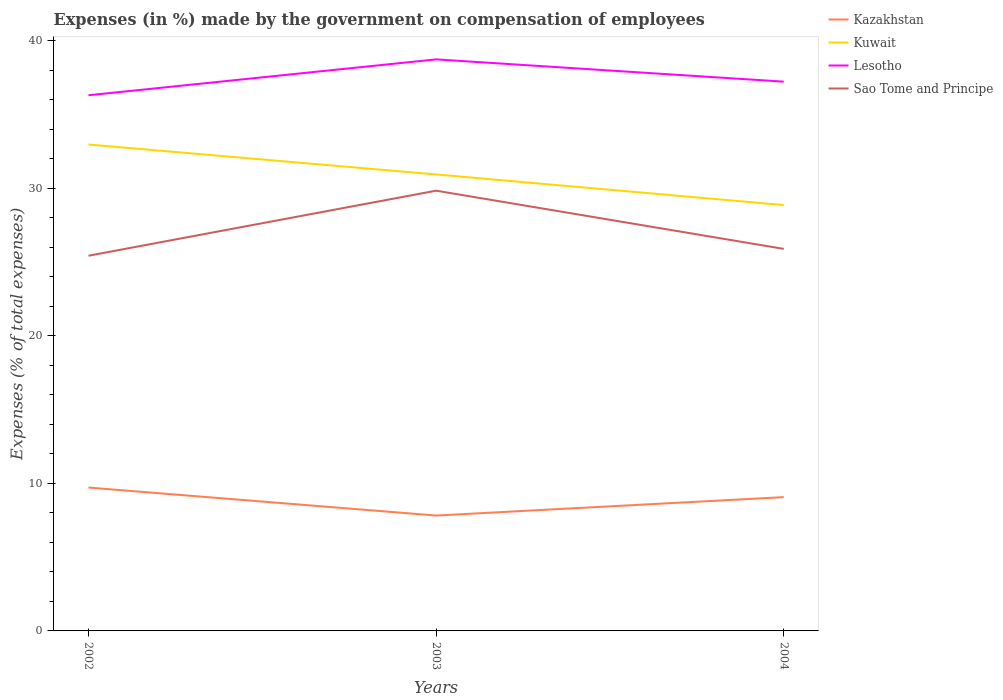How many different coloured lines are there?
Give a very brief answer. 4. Across all years, what is the maximum percentage of expenses made by the government on compensation of employees in Lesotho?
Ensure brevity in your answer.  36.29. In which year was the percentage of expenses made by the government on compensation of employees in Kuwait maximum?
Give a very brief answer. 2004. What is the total percentage of expenses made by the government on compensation of employees in Sao Tome and Principe in the graph?
Ensure brevity in your answer.  -0.46. What is the difference between the highest and the second highest percentage of expenses made by the government on compensation of employees in Lesotho?
Provide a short and direct response. 2.43. What is the difference between the highest and the lowest percentage of expenses made by the government on compensation of employees in Lesotho?
Ensure brevity in your answer.  1. How many lines are there?
Provide a short and direct response. 4. What is the difference between two consecutive major ticks on the Y-axis?
Make the answer very short. 10. Are the values on the major ticks of Y-axis written in scientific E-notation?
Provide a succinct answer. No. Does the graph contain any zero values?
Offer a terse response. No. Where does the legend appear in the graph?
Your answer should be compact. Top right. How many legend labels are there?
Offer a terse response. 4. What is the title of the graph?
Your answer should be compact. Expenses (in %) made by the government on compensation of employees. What is the label or title of the X-axis?
Provide a succinct answer. Years. What is the label or title of the Y-axis?
Provide a short and direct response. Expenses (% of total expenses). What is the Expenses (% of total expenses) in Kazakhstan in 2002?
Offer a very short reply. 9.71. What is the Expenses (% of total expenses) of Kuwait in 2002?
Your answer should be very brief. 32.96. What is the Expenses (% of total expenses) in Lesotho in 2002?
Make the answer very short. 36.29. What is the Expenses (% of total expenses) of Sao Tome and Principe in 2002?
Your answer should be very brief. 25.42. What is the Expenses (% of total expenses) in Kazakhstan in 2003?
Offer a terse response. 7.82. What is the Expenses (% of total expenses) in Kuwait in 2003?
Make the answer very short. 30.93. What is the Expenses (% of total expenses) in Lesotho in 2003?
Your answer should be compact. 38.72. What is the Expenses (% of total expenses) of Sao Tome and Principe in 2003?
Provide a succinct answer. 29.83. What is the Expenses (% of total expenses) of Kazakhstan in 2004?
Offer a terse response. 9.07. What is the Expenses (% of total expenses) in Kuwait in 2004?
Offer a very short reply. 28.85. What is the Expenses (% of total expenses) in Lesotho in 2004?
Your answer should be very brief. 37.21. What is the Expenses (% of total expenses) of Sao Tome and Principe in 2004?
Make the answer very short. 25.88. Across all years, what is the maximum Expenses (% of total expenses) in Kazakhstan?
Your answer should be compact. 9.71. Across all years, what is the maximum Expenses (% of total expenses) in Kuwait?
Offer a very short reply. 32.96. Across all years, what is the maximum Expenses (% of total expenses) of Lesotho?
Make the answer very short. 38.72. Across all years, what is the maximum Expenses (% of total expenses) in Sao Tome and Principe?
Provide a short and direct response. 29.83. Across all years, what is the minimum Expenses (% of total expenses) of Kazakhstan?
Offer a very short reply. 7.82. Across all years, what is the minimum Expenses (% of total expenses) in Kuwait?
Give a very brief answer. 28.85. Across all years, what is the minimum Expenses (% of total expenses) of Lesotho?
Your answer should be very brief. 36.29. Across all years, what is the minimum Expenses (% of total expenses) of Sao Tome and Principe?
Your answer should be compact. 25.42. What is the total Expenses (% of total expenses) of Kazakhstan in the graph?
Your answer should be very brief. 26.6. What is the total Expenses (% of total expenses) of Kuwait in the graph?
Give a very brief answer. 92.74. What is the total Expenses (% of total expenses) of Lesotho in the graph?
Your answer should be very brief. 112.23. What is the total Expenses (% of total expenses) of Sao Tome and Principe in the graph?
Ensure brevity in your answer.  81.13. What is the difference between the Expenses (% of total expenses) in Kazakhstan in 2002 and that in 2003?
Give a very brief answer. 1.9. What is the difference between the Expenses (% of total expenses) in Kuwait in 2002 and that in 2003?
Give a very brief answer. 2.03. What is the difference between the Expenses (% of total expenses) of Lesotho in 2002 and that in 2003?
Offer a terse response. -2.43. What is the difference between the Expenses (% of total expenses) of Sao Tome and Principe in 2002 and that in 2003?
Offer a terse response. -4.41. What is the difference between the Expenses (% of total expenses) of Kazakhstan in 2002 and that in 2004?
Provide a short and direct response. 0.65. What is the difference between the Expenses (% of total expenses) of Kuwait in 2002 and that in 2004?
Your answer should be very brief. 4.1. What is the difference between the Expenses (% of total expenses) of Lesotho in 2002 and that in 2004?
Your answer should be very brief. -0.92. What is the difference between the Expenses (% of total expenses) in Sao Tome and Principe in 2002 and that in 2004?
Offer a terse response. -0.46. What is the difference between the Expenses (% of total expenses) in Kazakhstan in 2003 and that in 2004?
Your answer should be compact. -1.25. What is the difference between the Expenses (% of total expenses) in Kuwait in 2003 and that in 2004?
Make the answer very short. 2.07. What is the difference between the Expenses (% of total expenses) in Lesotho in 2003 and that in 2004?
Your answer should be very brief. 1.51. What is the difference between the Expenses (% of total expenses) of Sao Tome and Principe in 2003 and that in 2004?
Provide a succinct answer. 3.94. What is the difference between the Expenses (% of total expenses) in Kazakhstan in 2002 and the Expenses (% of total expenses) in Kuwait in 2003?
Your answer should be very brief. -21.21. What is the difference between the Expenses (% of total expenses) of Kazakhstan in 2002 and the Expenses (% of total expenses) of Lesotho in 2003?
Your answer should be very brief. -29.01. What is the difference between the Expenses (% of total expenses) of Kazakhstan in 2002 and the Expenses (% of total expenses) of Sao Tome and Principe in 2003?
Provide a succinct answer. -20.11. What is the difference between the Expenses (% of total expenses) of Kuwait in 2002 and the Expenses (% of total expenses) of Lesotho in 2003?
Give a very brief answer. -5.77. What is the difference between the Expenses (% of total expenses) of Kuwait in 2002 and the Expenses (% of total expenses) of Sao Tome and Principe in 2003?
Offer a terse response. 3.13. What is the difference between the Expenses (% of total expenses) in Lesotho in 2002 and the Expenses (% of total expenses) in Sao Tome and Principe in 2003?
Make the answer very short. 6.46. What is the difference between the Expenses (% of total expenses) in Kazakhstan in 2002 and the Expenses (% of total expenses) in Kuwait in 2004?
Your answer should be very brief. -19.14. What is the difference between the Expenses (% of total expenses) of Kazakhstan in 2002 and the Expenses (% of total expenses) of Lesotho in 2004?
Ensure brevity in your answer.  -27.5. What is the difference between the Expenses (% of total expenses) in Kazakhstan in 2002 and the Expenses (% of total expenses) in Sao Tome and Principe in 2004?
Offer a terse response. -16.17. What is the difference between the Expenses (% of total expenses) of Kuwait in 2002 and the Expenses (% of total expenses) of Lesotho in 2004?
Your answer should be compact. -4.26. What is the difference between the Expenses (% of total expenses) in Kuwait in 2002 and the Expenses (% of total expenses) in Sao Tome and Principe in 2004?
Your answer should be very brief. 7.07. What is the difference between the Expenses (% of total expenses) in Lesotho in 2002 and the Expenses (% of total expenses) in Sao Tome and Principe in 2004?
Provide a short and direct response. 10.41. What is the difference between the Expenses (% of total expenses) of Kazakhstan in 2003 and the Expenses (% of total expenses) of Kuwait in 2004?
Keep it short and to the point. -21.04. What is the difference between the Expenses (% of total expenses) of Kazakhstan in 2003 and the Expenses (% of total expenses) of Lesotho in 2004?
Your response must be concise. -29.4. What is the difference between the Expenses (% of total expenses) in Kazakhstan in 2003 and the Expenses (% of total expenses) in Sao Tome and Principe in 2004?
Your response must be concise. -18.07. What is the difference between the Expenses (% of total expenses) of Kuwait in 2003 and the Expenses (% of total expenses) of Lesotho in 2004?
Offer a terse response. -6.29. What is the difference between the Expenses (% of total expenses) of Kuwait in 2003 and the Expenses (% of total expenses) of Sao Tome and Principe in 2004?
Your response must be concise. 5.04. What is the difference between the Expenses (% of total expenses) of Lesotho in 2003 and the Expenses (% of total expenses) of Sao Tome and Principe in 2004?
Give a very brief answer. 12.84. What is the average Expenses (% of total expenses) of Kazakhstan per year?
Provide a succinct answer. 8.87. What is the average Expenses (% of total expenses) of Kuwait per year?
Give a very brief answer. 30.91. What is the average Expenses (% of total expenses) in Lesotho per year?
Your response must be concise. 37.41. What is the average Expenses (% of total expenses) of Sao Tome and Principe per year?
Offer a very short reply. 27.04. In the year 2002, what is the difference between the Expenses (% of total expenses) of Kazakhstan and Expenses (% of total expenses) of Kuwait?
Give a very brief answer. -23.24. In the year 2002, what is the difference between the Expenses (% of total expenses) in Kazakhstan and Expenses (% of total expenses) in Lesotho?
Offer a terse response. -26.58. In the year 2002, what is the difference between the Expenses (% of total expenses) in Kazakhstan and Expenses (% of total expenses) in Sao Tome and Principe?
Give a very brief answer. -15.71. In the year 2002, what is the difference between the Expenses (% of total expenses) in Kuwait and Expenses (% of total expenses) in Lesotho?
Your response must be concise. -3.34. In the year 2002, what is the difference between the Expenses (% of total expenses) of Kuwait and Expenses (% of total expenses) of Sao Tome and Principe?
Offer a terse response. 7.54. In the year 2002, what is the difference between the Expenses (% of total expenses) in Lesotho and Expenses (% of total expenses) in Sao Tome and Principe?
Your answer should be very brief. 10.87. In the year 2003, what is the difference between the Expenses (% of total expenses) in Kazakhstan and Expenses (% of total expenses) in Kuwait?
Offer a very short reply. -23.11. In the year 2003, what is the difference between the Expenses (% of total expenses) in Kazakhstan and Expenses (% of total expenses) in Lesotho?
Provide a succinct answer. -30.91. In the year 2003, what is the difference between the Expenses (% of total expenses) in Kazakhstan and Expenses (% of total expenses) in Sao Tome and Principe?
Provide a succinct answer. -22.01. In the year 2003, what is the difference between the Expenses (% of total expenses) of Kuwait and Expenses (% of total expenses) of Lesotho?
Your answer should be very brief. -7.8. In the year 2003, what is the difference between the Expenses (% of total expenses) of Kuwait and Expenses (% of total expenses) of Sao Tome and Principe?
Your answer should be compact. 1.1. In the year 2003, what is the difference between the Expenses (% of total expenses) in Lesotho and Expenses (% of total expenses) in Sao Tome and Principe?
Your response must be concise. 8.9. In the year 2004, what is the difference between the Expenses (% of total expenses) of Kazakhstan and Expenses (% of total expenses) of Kuwait?
Offer a very short reply. -19.79. In the year 2004, what is the difference between the Expenses (% of total expenses) of Kazakhstan and Expenses (% of total expenses) of Lesotho?
Your response must be concise. -28.15. In the year 2004, what is the difference between the Expenses (% of total expenses) of Kazakhstan and Expenses (% of total expenses) of Sao Tome and Principe?
Provide a short and direct response. -16.82. In the year 2004, what is the difference between the Expenses (% of total expenses) in Kuwait and Expenses (% of total expenses) in Lesotho?
Offer a terse response. -8.36. In the year 2004, what is the difference between the Expenses (% of total expenses) in Kuwait and Expenses (% of total expenses) in Sao Tome and Principe?
Make the answer very short. 2.97. In the year 2004, what is the difference between the Expenses (% of total expenses) of Lesotho and Expenses (% of total expenses) of Sao Tome and Principe?
Offer a terse response. 11.33. What is the ratio of the Expenses (% of total expenses) in Kazakhstan in 2002 to that in 2003?
Your answer should be very brief. 1.24. What is the ratio of the Expenses (% of total expenses) of Kuwait in 2002 to that in 2003?
Offer a terse response. 1.07. What is the ratio of the Expenses (% of total expenses) of Lesotho in 2002 to that in 2003?
Offer a very short reply. 0.94. What is the ratio of the Expenses (% of total expenses) in Sao Tome and Principe in 2002 to that in 2003?
Make the answer very short. 0.85. What is the ratio of the Expenses (% of total expenses) in Kazakhstan in 2002 to that in 2004?
Ensure brevity in your answer.  1.07. What is the ratio of the Expenses (% of total expenses) in Kuwait in 2002 to that in 2004?
Make the answer very short. 1.14. What is the ratio of the Expenses (% of total expenses) of Lesotho in 2002 to that in 2004?
Your response must be concise. 0.98. What is the ratio of the Expenses (% of total expenses) of Sao Tome and Principe in 2002 to that in 2004?
Ensure brevity in your answer.  0.98. What is the ratio of the Expenses (% of total expenses) in Kazakhstan in 2003 to that in 2004?
Your answer should be very brief. 0.86. What is the ratio of the Expenses (% of total expenses) in Kuwait in 2003 to that in 2004?
Make the answer very short. 1.07. What is the ratio of the Expenses (% of total expenses) of Lesotho in 2003 to that in 2004?
Provide a succinct answer. 1.04. What is the ratio of the Expenses (% of total expenses) of Sao Tome and Principe in 2003 to that in 2004?
Make the answer very short. 1.15. What is the difference between the highest and the second highest Expenses (% of total expenses) in Kazakhstan?
Your response must be concise. 0.65. What is the difference between the highest and the second highest Expenses (% of total expenses) of Kuwait?
Your response must be concise. 2.03. What is the difference between the highest and the second highest Expenses (% of total expenses) of Lesotho?
Your response must be concise. 1.51. What is the difference between the highest and the second highest Expenses (% of total expenses) in Sao Tome and Principe?
Your answer should be compact. 3.94. What is the difference between the highest and the lowest Expenses (% of total expenses) of Kazakhstan?
Keep it short and to the point. 1.9. What is the difference between the highest and the lowest Expenses (% of total expenses) of Kuwait?
Your answer should be compact. 4.1. What is the difference between the highest and the lowest Expenses (% of total expenses) in Lesotho?
Provide a succinct answer. 2.43. What is the difference between the highest and the lowest Expenses (% of total expenses) of Sao Tome and Principe?
Keep it short and to the point. 4.41. 